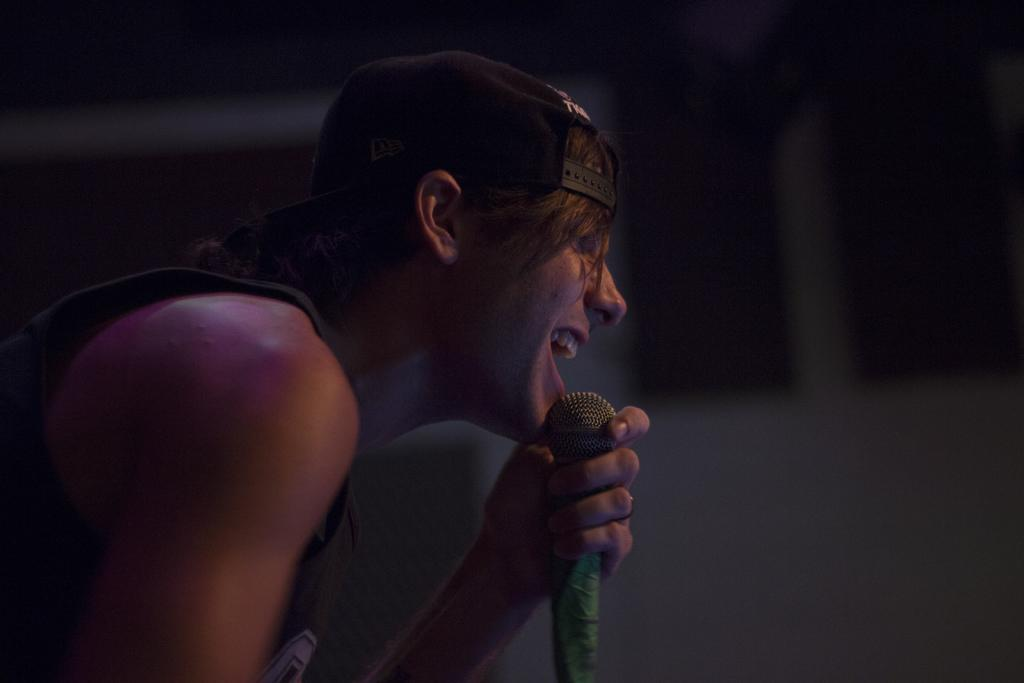What is the main subject of the image? There is a person in the image. What is the person wearing? The person is wearing a black hat. What is the person doing in the image? The person is singing. What object is the person standing in front of? The person is standing in front of a microphone. What type of sugar is being used to sweeten the horse's food in the image? There is no horse or sugar present in the image; it features a person singing in front of a microphone. 